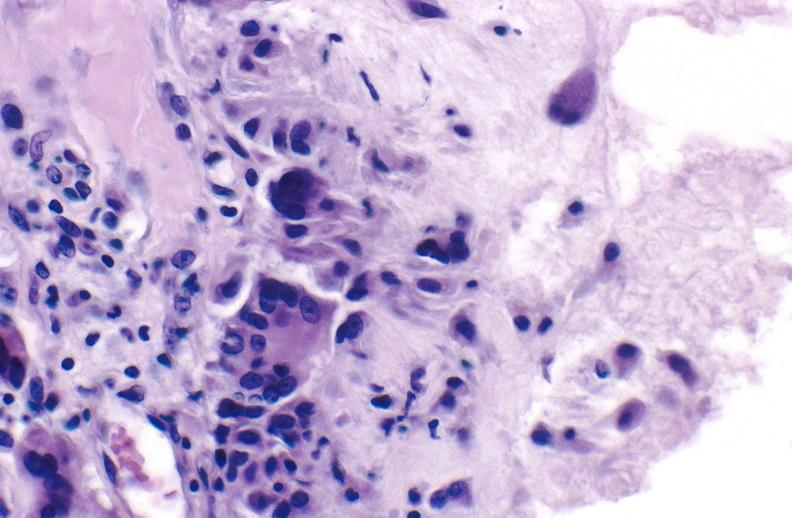what is present?
Answer the question using a single word or phrase. Joints 